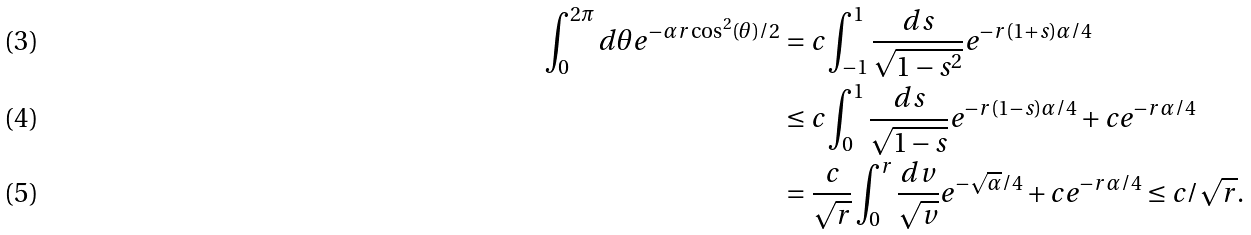Convert formula to latex. <formula><loc_0><loc_0><loc_500><loc_500>\int _ { 0 } ^ { 2 \pi } d \theta e ^ { - \alpha r \cos ^ { 2 } ( \theta ) / 2 } & = c \int _ { - 1 } ^ { 1 } \frac { d s } { \sqrt { 1 - s ^ { 2 } } } e ^ { - r ( 1 + s ) \alpha / 4 } \\ & \leq c \int _ { 0 } ^ { 1 } \frac { d s } { \sqrt { 1 - s } } e ^ { - r ( 1 - s ) \alpha / 4 } + c e ^ { - r \alpha / 4 } \\ & = \frac { c } { \sqrt { r } } \int _ { 0 } ^ { r } \frac { d v } { \sqrt { v } } e ^ { - \sqrt { \alpha } / 4 } + c e ^ { - r \alpha / 4 } \leq c / \sqrt { r } .</formula> 